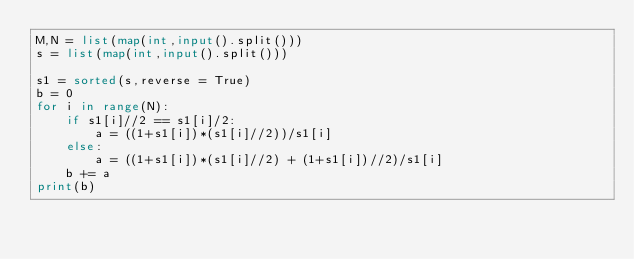<code> <loc_0><loc_0><loc_500><loc_500><_Python_>M,N = list(map(int,input().split()))
s = list(map(int,input().split()))
 
s1 = sorted(s,reverse = True)
b = 0
for i in range(N):
    if s1[i]//2 == s1[i]/2:
        a = ((1+s1[i])*(s1[i]//2))/s1[i]
    else:
        a = ((1+s1[i])*(s1[i]//2) + (1+s1[i])//2)/s1[i]
    b += a
print(b)</code> 